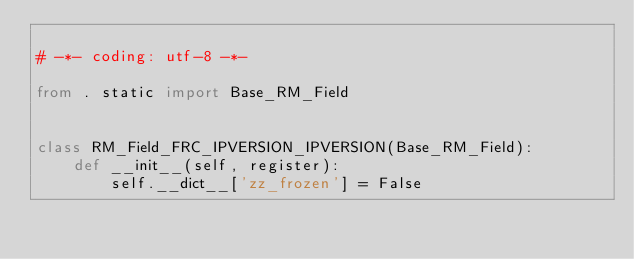<code> <loc_0><loc_0><loc_500><loc_500><_Python_>
# -*- coding: utf-8 -*-

from . static import Base_RM_Field


class RM_Field_FRC_IPVERSION_IPVERSION(Base_RM_Field):
    def __init__(self, register):
        self.__dict__['zz_frozen'] = False</code> 